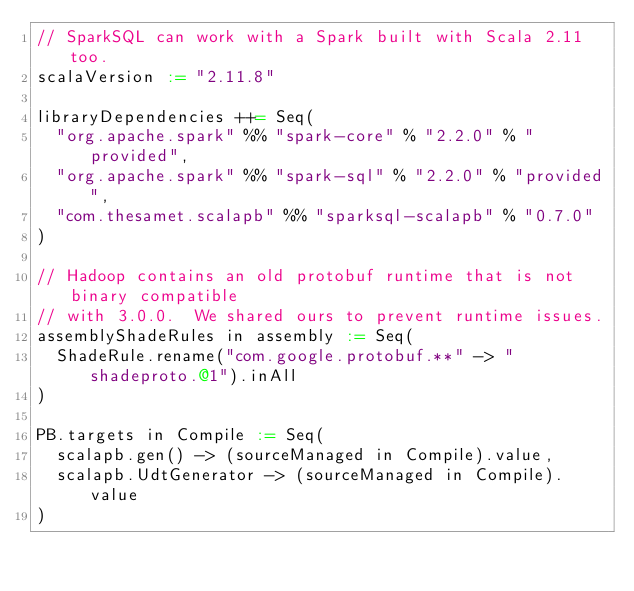<code> <loc_0><loc_0><loc_500><loc_500><_Scala_>// SparkSQL can work with a Spark built with Scala 2.11 too.
scalaVersion := "2.11.8"

libraryDependencies ++= Seq(
  "org.apache.spark" %% "spark-core" % "2.2.0" % "provided",
  "org.apache.spark" %% "spark-sql" % "2.2.0" % "provided",
  "com.thesamet.scalapb" %% "sparksql-scalapb" % "0.7.0"
)

// Hadoop contains an old protobuf runtime that is not binary compatible
// with 3.0.0.  We shared ours to prevent runtime issues.
assemblyShadeRules in assembly := Seq(
  ShadeRule.rename("com.google.protobuf.**" -> "shadeproto.@1").inAll
)

PB.targets in Compile := Seq(
  scalapb.gen() -> (sourceManaged in Compile).value,
  scalapb.UdtGenerator -> (sourceManaged in Compile).value
)

</code> 